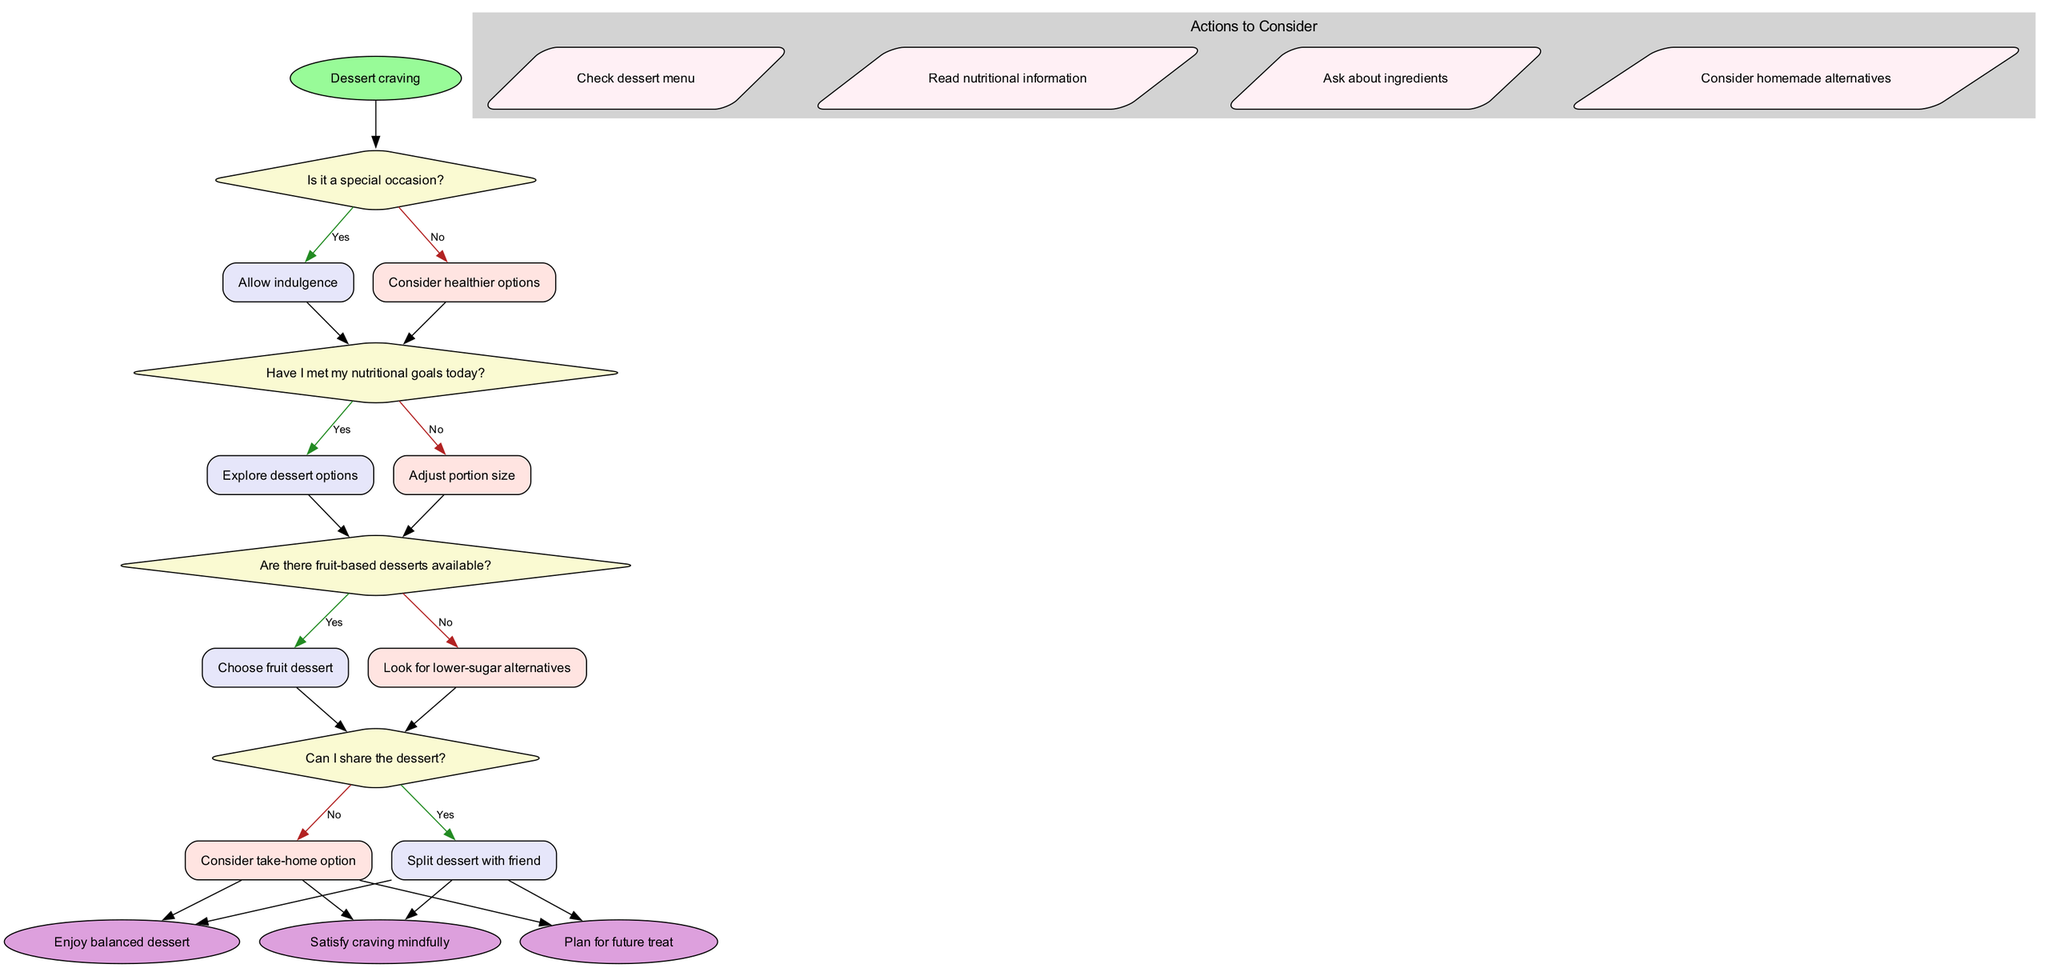What is the starting point of the flowchart? The starting point of the flowchart is labeled as "Dessert craving," which is where the decision-making process begins.
Answer: Dessert craving How many decision nodes are in the diagram? There are four decision nodes represented in the diagram, each asking a question related to choosing a balanced dessert option.
Answer: 4 What action might be taken if I have not met my nutritional goals today? If the nutritional goals have not been met, the flowchart suggests adjusting the portion size as a potential action to consider.
Answer: Adjust portion size What is the outcome if I can share the dessert? If sharing the dessert is possible, the flowchart indicates that the option is to split the dessert with a friend, leading to a positive outcome.
Answer: Split dessert with friend What happens if I choose a non-fruit dessert? If there are no fruit-based desserts available, the next decision point leads to looking for lower-sugar alternatives, ensuring a healthier choice.
Answer: Look for lower-sugar alternatives If I allow indulgence, what is the final result? Allowing indulgence enables one to enjoy a balanced dessert, which is one of the satisfying outcomes of the decision flow.
Answer: Enjoy balanced dessert What is the relationship between the decision to explore dessert options and nutritional goals? The decision to explore dessert options occurs only if the nutritional goals for the day have been met, indicating that meeting these goals is a prerequisite.
Answer: Nutritional goals How do actions to consider relate to the outcome of enjoying a balanced dessert? The actions to consider, such as checking the dessert menu and reading nutritional information, guide the decision-making process, ultimately leading to the outcome of enjoying a balanced dessert.
Answer: Guide decision-making process 